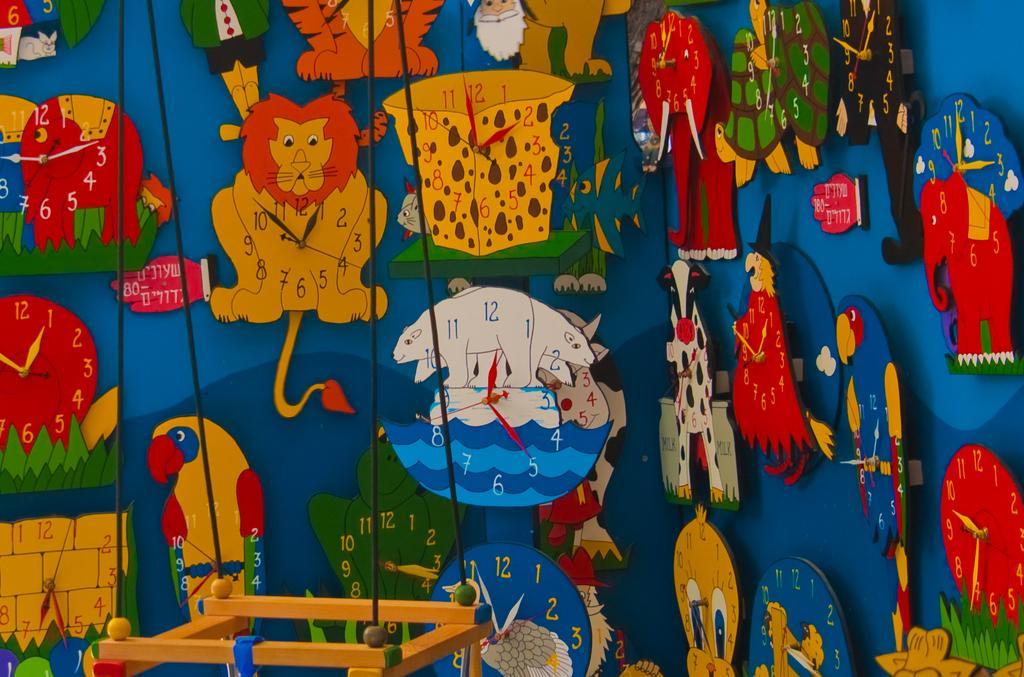Could you give a brief overview of what you see in this image? In the picture we can see the wall with full of clocks in the shape of cartoon animals shape and in from it we can see a hanging with some wires. 